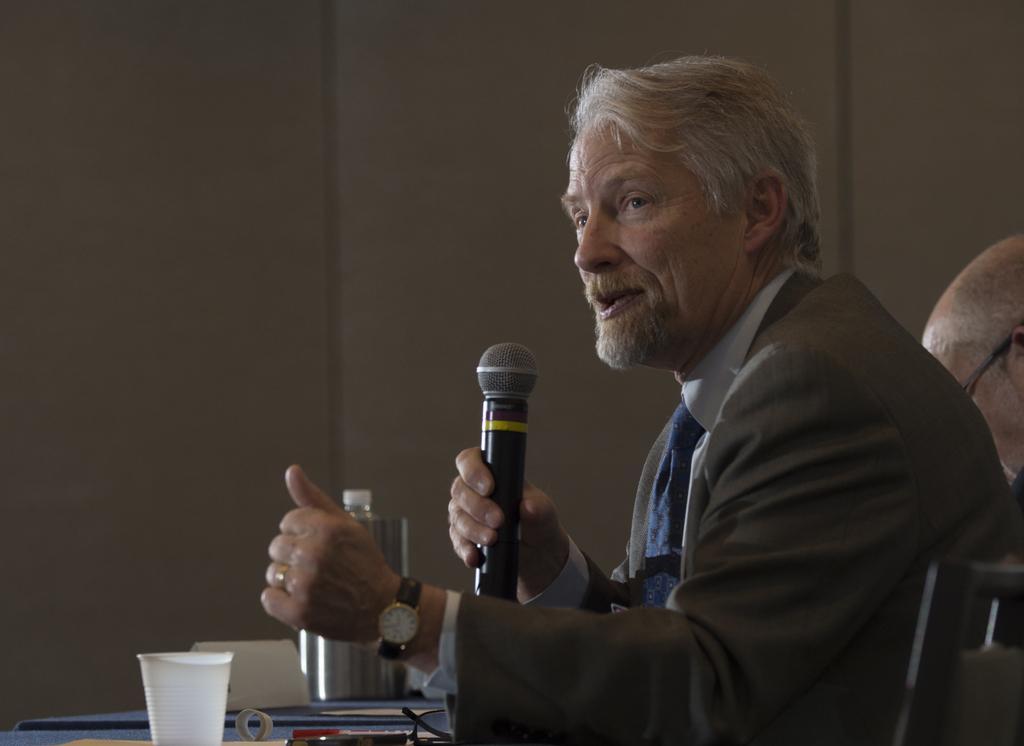Could you give a brief overview of what you see in this image? In this image we can see this person wearing blazer, tie and wrist watch is holding a mic and standing near the table on which we can see glass, spectacles and a few more objects are kept. In the background, we can see another person and the wall. 